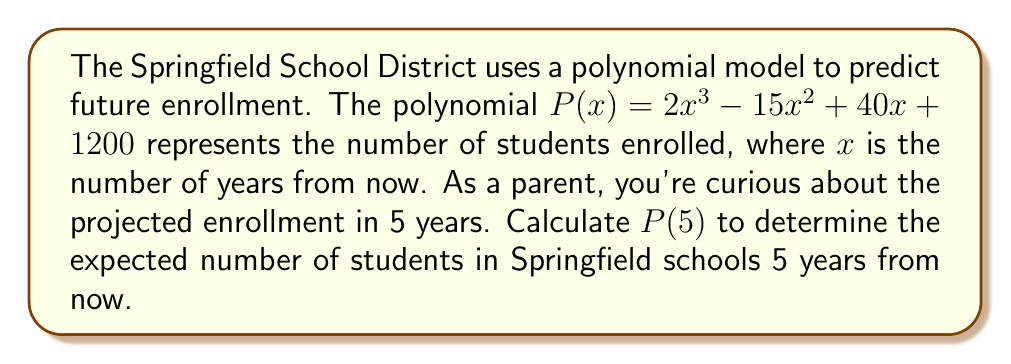Help me with this question. To evaluate the polynomial $P(x) = 2x^3 - 15x^2 + 40x + 1200$ at $x = 5$, we need to substitute 5 for x and calculate the result:

1) First, let's evaluate each term:
   
   $2x^3$ becomes $2(5^3) = 2(125) = 250$
   $-15x^2$ becomes $-15(5^2) = -15(25) = -375$
   $40x$ becomes $40(5) = 200$
   $1200$ remains as is

2) Now, we add all these terms:

   $P(5) = 250 - 375 + 200 + 1200$

3) Simplifying:
   
   $P(5) = 1275$

Therefore, the predicted enrollment in Springfield schools 5 years from now is 1,275 students.
Answer: 1,275 students 